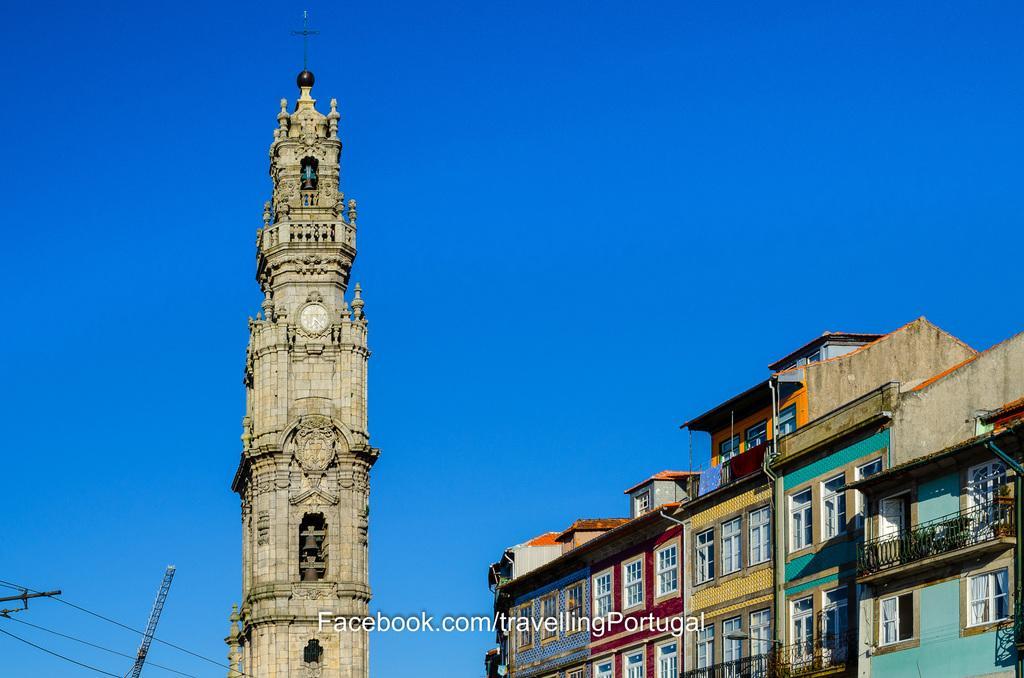Could you give a brief overview of what you see in this image? In this image we can see buildings, windows, railing, there is a tower, a cross symbol, also we can see the wires, and the sky. 